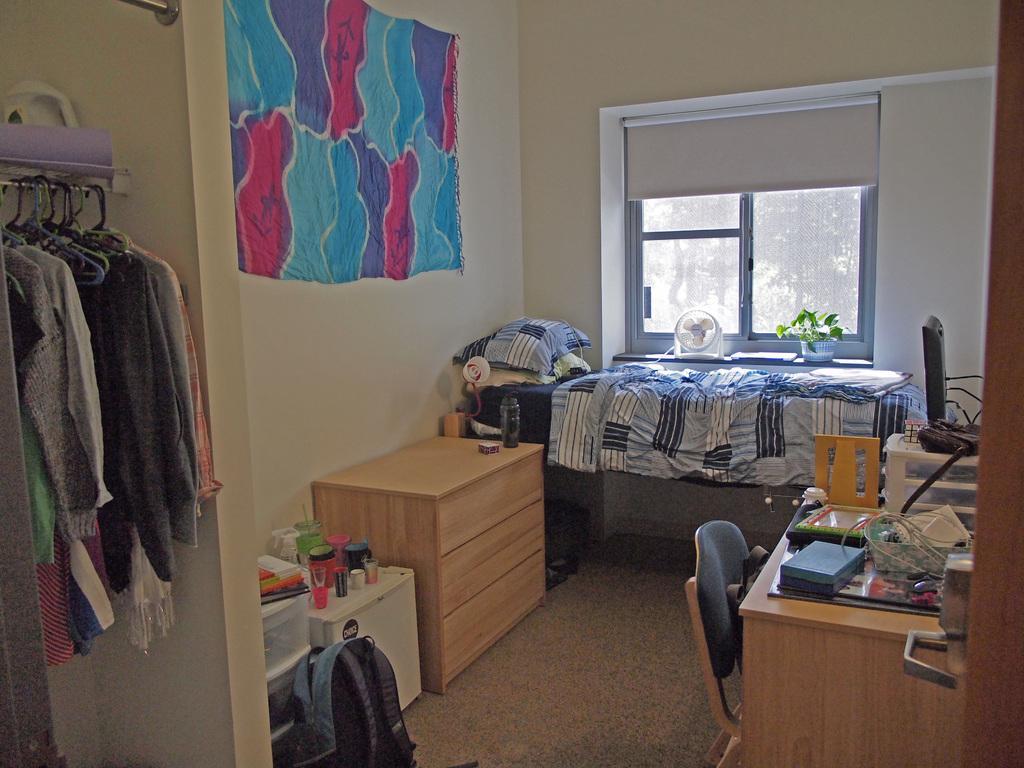Please provide a concise description of this image. In this picture we can see a room with clothes hanged, table and on table we can see books, covers beside to this we have chair and cupboards here we can see bag, wall, window, fan, flower pot with plant in it, pillow, bottle. 